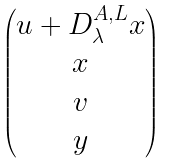Convert formula to latex. <formula><loc_0><loc_0><loc_500><loc_500>\begin{pmatrix} u + D ^ { A , L } _ { \lambda } x \\ x \\ v \\ y \end{pmatrix}</formula> 